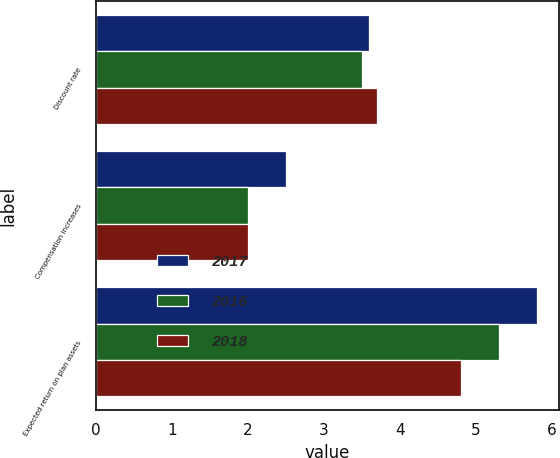Convert chart to OTSL. <chart><loc_0><loc_0><loc_500><loc_500><stacked_bar_chart><ecel><fcel>Discount rate<fcel>Compensation increases<fcel>Expected return on plan assets<nl><fcel>2017<fcel>3.6<fcel>2.5<fcel>5.8<nl><fcel>2016<fcel>3.5<fcel>2<fcel>5.3<nl><fcel>2018<fcel>3.7<fcel>2<fcel>4.8<nl></chart> 